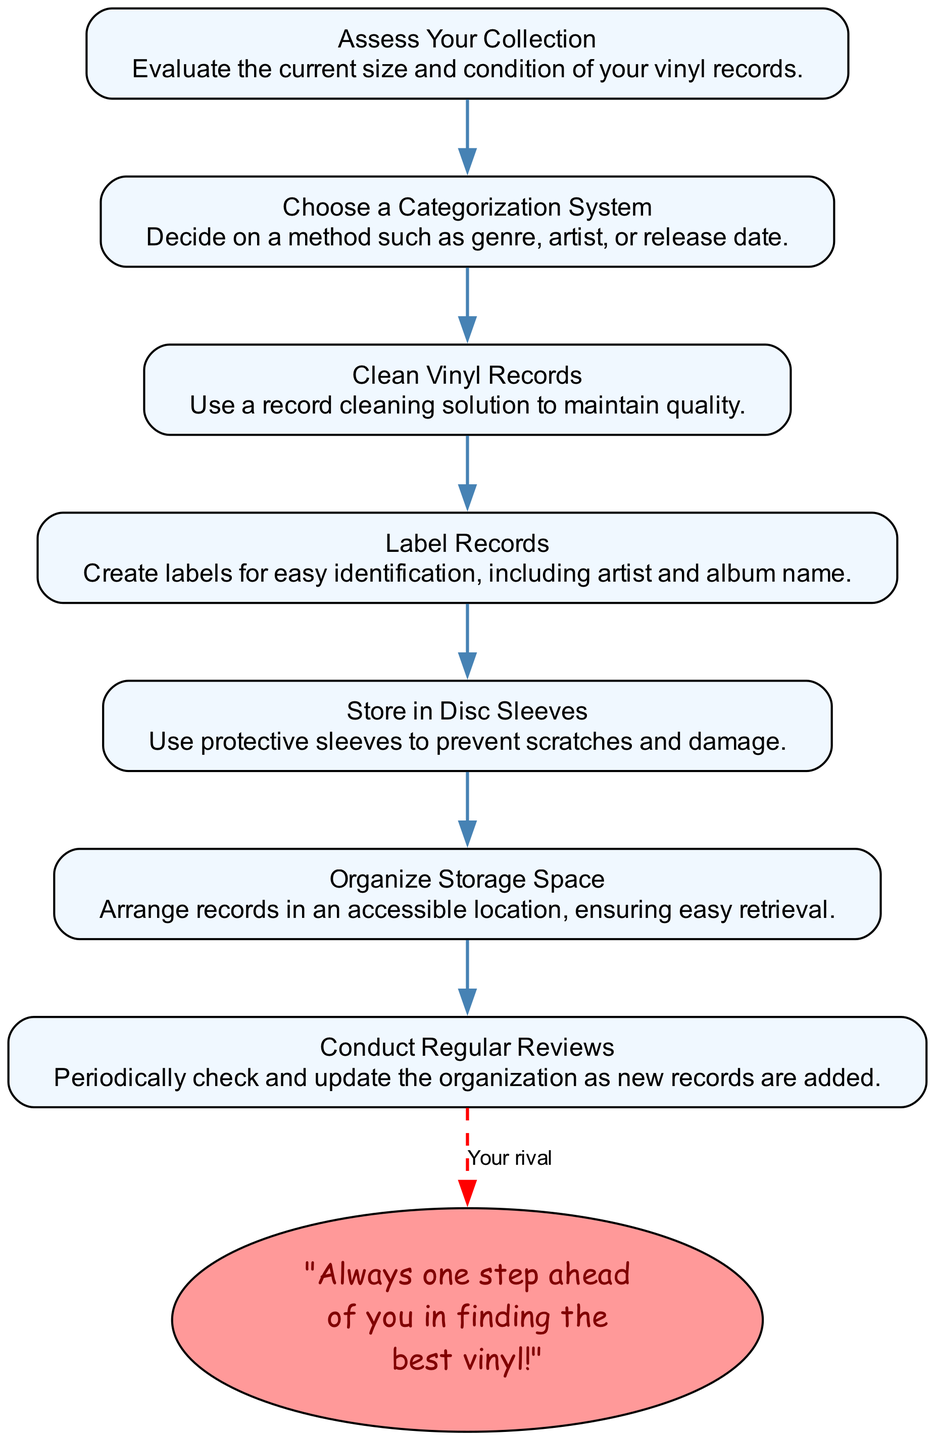What is the first step in the workflow? The first step is represented by the node labeled "Assess Your Collection." This is identified as the starting point in the flowchart.
Answer: Assess Your Collection How many total steps are in the workflow? By counting the nodes in the diagram, there are seven steps listed in the workflow.
Answer: 7 What does the second step involve? The second step labeled "Choose a Categorization System" involves deciding on a method for organizing the records, such as by genre, artist, or release date.
Answer: Choose a Categorization System What step comes before "Label Records"? To find which step comes before "Label Records," we look at the flow of the diagram and see that "Clean Vinyl Records" is directly prior to it.
Answer: Clean Vinyl Records What color are the nodes in the diagram? The nodes are filled with a light blue color, which is the designated style for the steps in the workflow according to the diagram's attributes.
Answer: Light blue What is the last step of the workflow? The last step, according to the flowchart, is "Conduct Regular Reviews," which signifies the ongoing process of checking the organization.
Answer: Conduct Regular Reviews How does a user know what to do after "Store in Disc Sleeves"? After "Store in Disc Sleeves," the user would proceed to the next indicated step in the flowchart, which is to "Organize Storage Space." This clearly shows the direction of workflow progression.
Answer: Organize Storage Space Which step is indicated by a dashed line? The step indicated by a dashed line is "Conduct Regular Reviews," which is connected to the snarky comment about being ahead in finding vinyl, highlighting a humorous rivalry.
Answer: Conduct Regular Reviews 